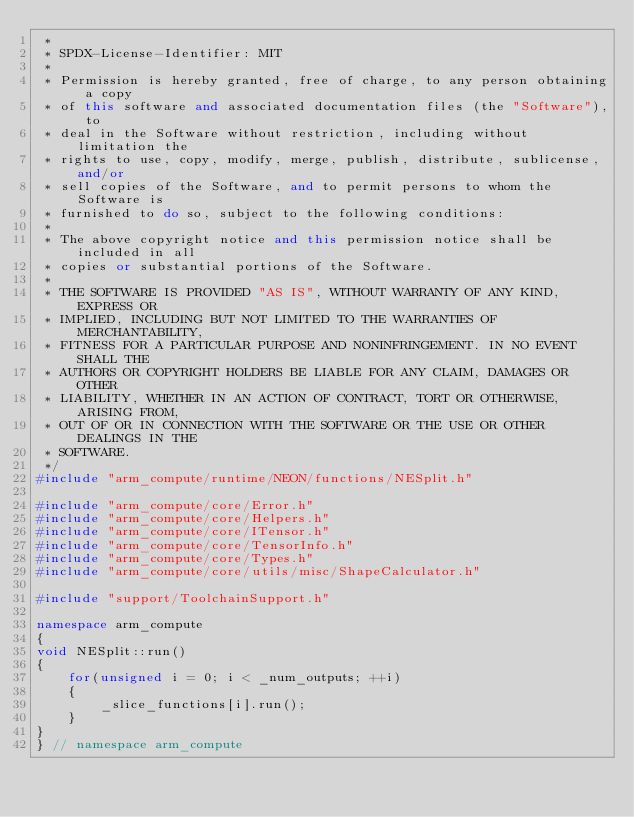<code> <loc_0><loc_0><loc_500><loc_500><_C++_> *
 * SPDX-License-Identifier: MIT
 *
 * Permission is hereby granted, free of charge, to any person obtaining a copy
 * of this software and associated documentation files (the "Software"), to
 * deal in the Software without restriction, including without limitation the
 * rights to use, copy, modify, merge, publish, distribute, sublicense, and/or
 * sell copies of the Software, and to permit persons to whom the Software is
 * furnished to do so, subject to the following conditions:
 *
 * The above copyright notice and this permission notice shall be included in all
 * copies or substantial portions of the Software.
 *
 * THE SOFTWARE IS PROVIDED "AS IS", WITHOUT WARRANTY OF ANY KIND, EXPRESS OR
 * IMPLIED, INCLUDING BUT NOT LIMITED TO THE WARRANTIES OF MERCHANTABILITY,
 * FITNESS FOR A PARTICULAR PURPOSE AND NONINFRINGEMENT. IN NO EVENT SHALL THE
 * AUTHORS OR COPYRIGHT HOLDERS BE LIABLE FOR ANY CLAIM, DAMAGES OR OTHER
 * LIABILITY, WHETHER IN AN ACTION OF CONTRACT, TORT OR OTHERWISE, ARISING FROM,
 * OUT OF OR IN CONNECTION WITH THE SOFTWARE OR THE USE OR OTHER DEALINGS IN THE
 * SOFTWARE.
 */
#include "arm_compute/runtime/NEON/functions/NESplit.h"

#include "arm_compute/core/Error.h"
#include "arm_compute/core/Helpers.h"
#include "arm_compute/core/ITensor.h"
#include "arm_compute/core/TensorInfo.h"
#include "arm_compute/core/Types.h"
#include "arm_compute/core/utils/misc/ShapeCalculator.h"

#include "support/ToolchainSupport.h"

namespace arm_compute
{
void NESplit::run()
{
    for(unsigned i = 0; i < _num_outputs; ++i)
    {
        _slice_functions[i].run();
    }
}
} // namespace arm_compute
</code> 